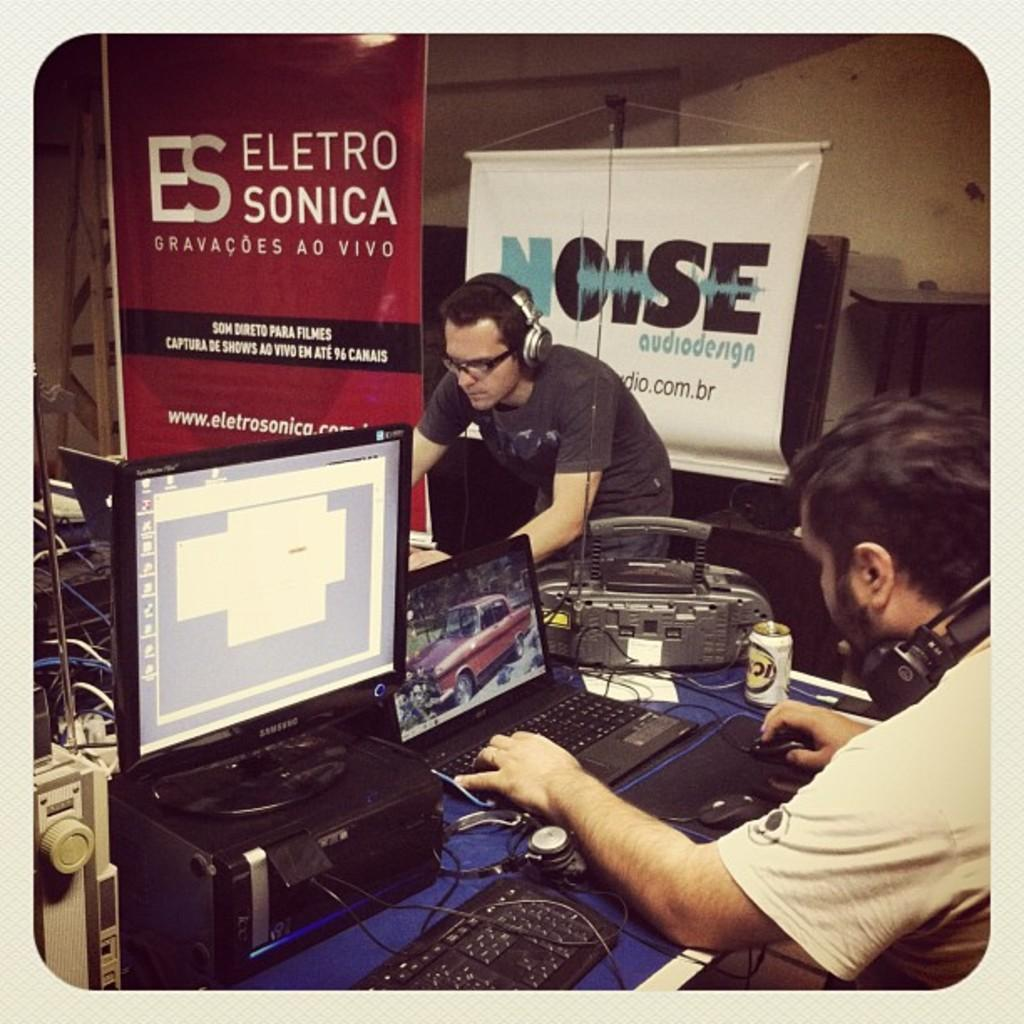<image>
Create a compact narrative representing the image presented. Eletro Sonica two guys with headphones on their laptops, 